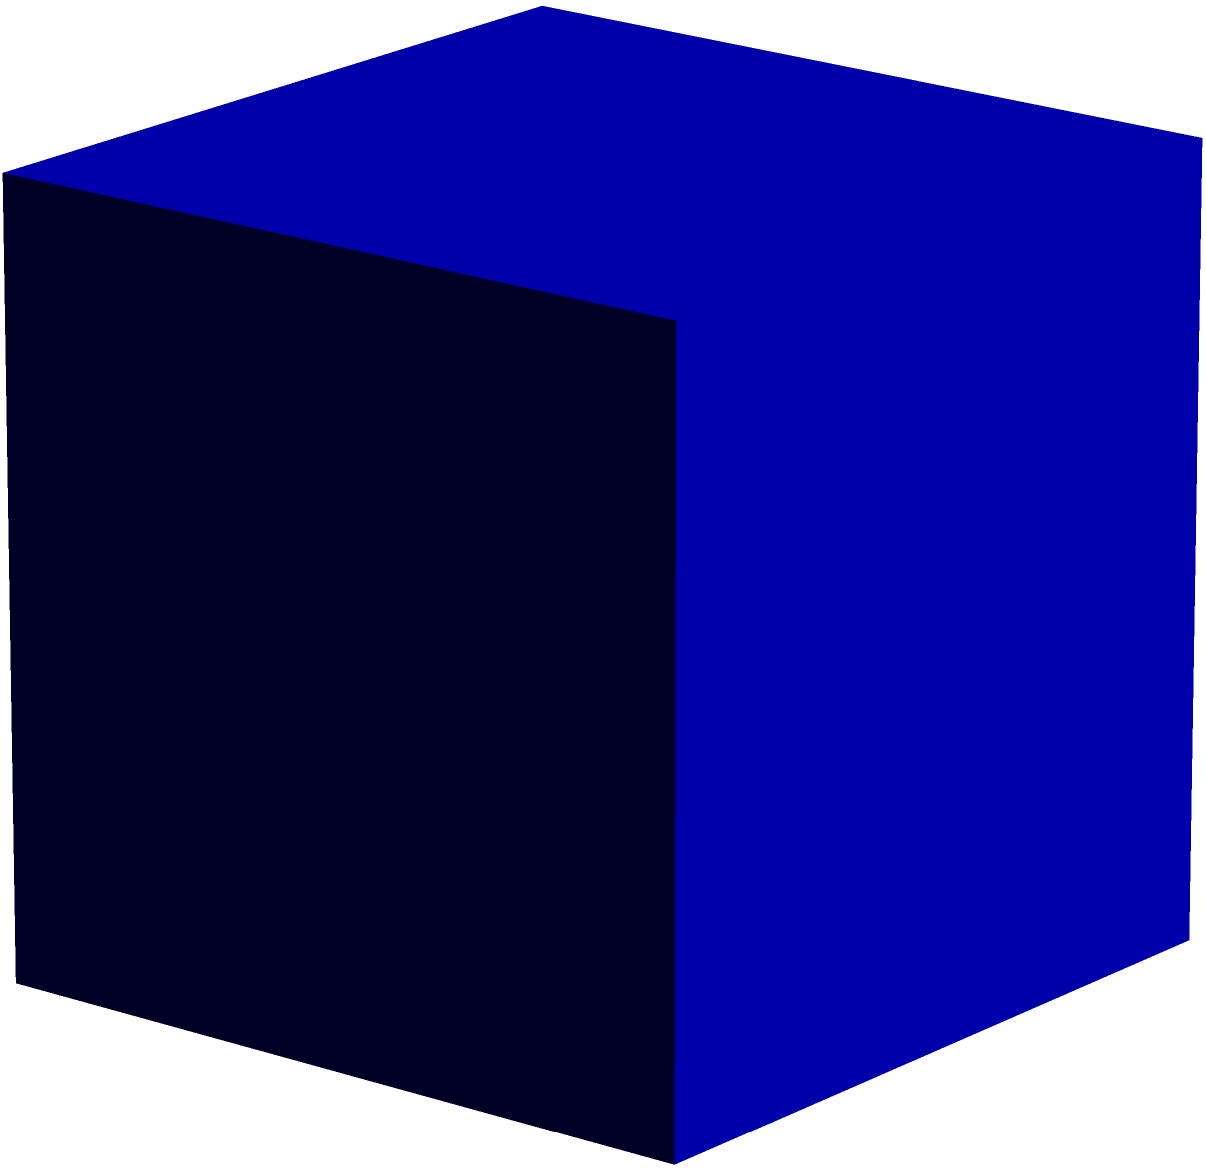Match the 2D shapes (A, B, C) at the bottom of the image with their corresponding 3D models (1, 2, 3) at the top. Which 2D shape corresponds to the 3D model labeled "2"? Let's analyze each 3D model and its corresponding 2D representation:

1. The 3D model labeled "1" is a cube. Its 2D representation would be a square, which is shape A.

2. The 3D model labeled "2" is a cylinder. When viewed from the top or bottom, a cylinder appears as a circle in 2D. This corresponds to shape B.

3. The 3D model labeled "3" is a sphere. While a sphere can be represented in various ways in 2D, one common method is to use a triangle to suggest its three-dimensional nature. This corresponds to shape C.

Therefore, the 2D shape that corresponds to the 3D model labeled "2" (the cylinder) is the circle, which is shape B.
Answer: B 